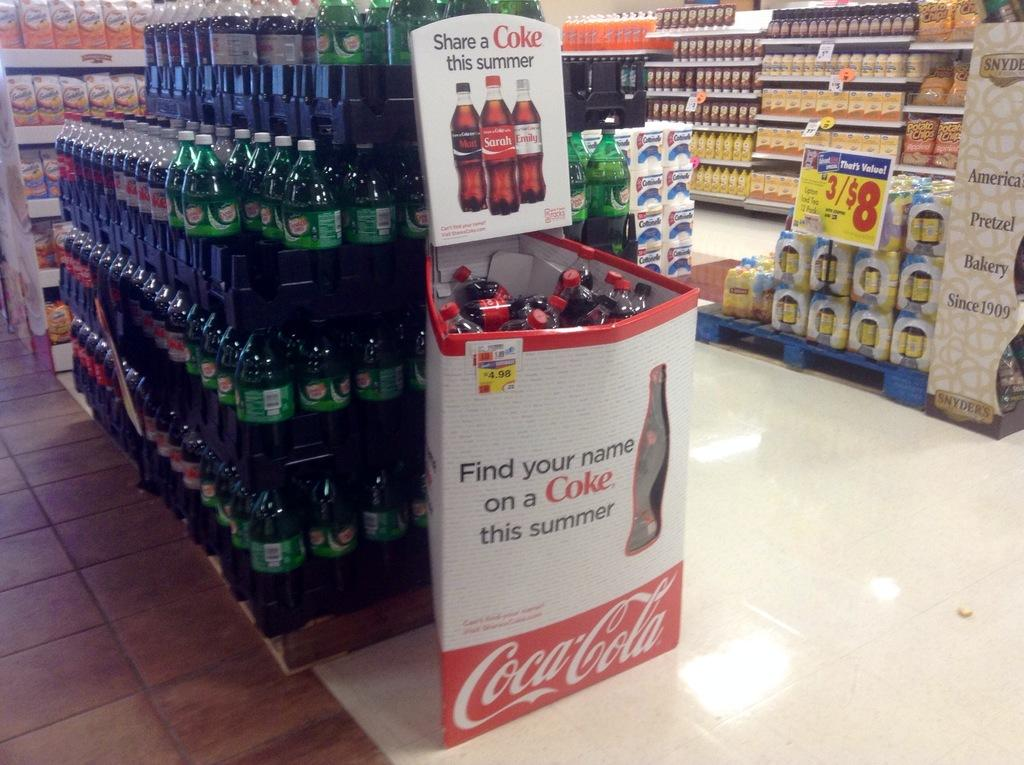<image>
Write a terse but informative summary of the picture. a grocery store aisle with an ad for coca-cola on the endcap 